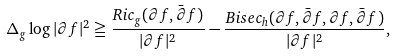<formula> <loc_0><loc_0><loc_500><loc_500>\Delta _ { g } \log | \partial f | ^ { 2 } \geqq \frac { R i c _ { g } ( \partial f , \bar { \partial } f ) } { | \partial f | ^ { 2 } } - \frac { B i s e c _ { h } ( \partial f , \bar { \partial } f , \partial f , \bar { \partial } f ) } { | \partial f | ^ { 2 } } ,</formula> 